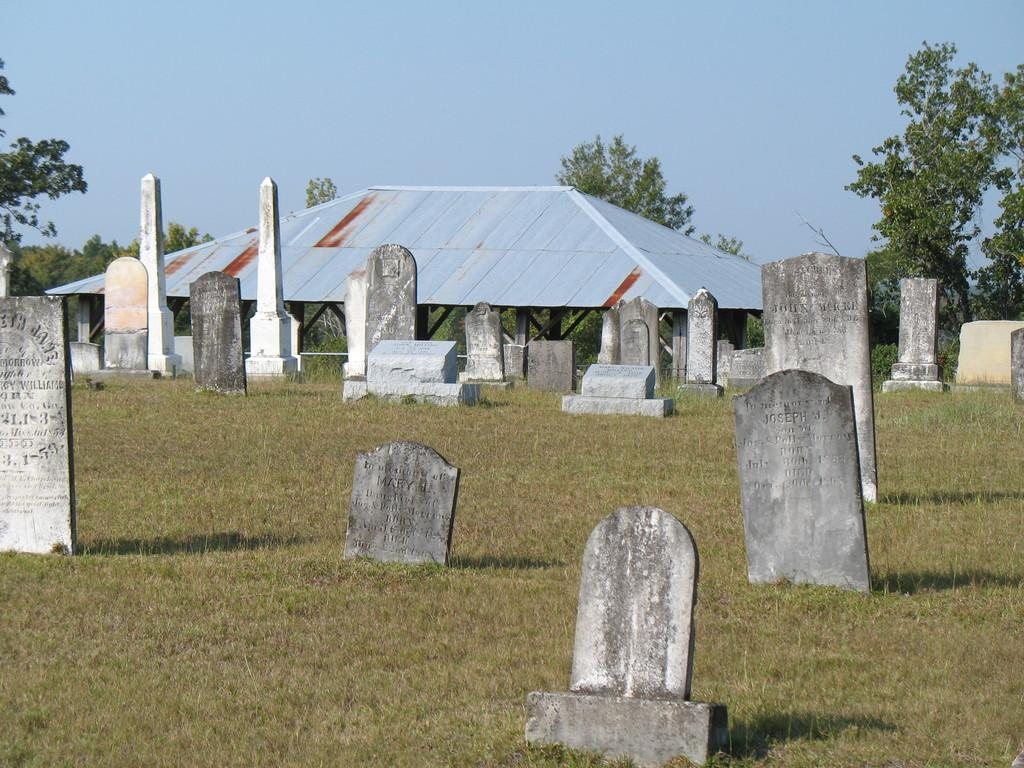What can be seen in the image that represents burial sites? There are graves in the image. What type of vegetation is present on the ground in the image? There is grass on the ground in the image. What structure can be seen in the background of the image? There is a shed in the background of the image. What else is visible in the background of the image besides the shed? There are trees and the sky visible in the background of the image. Can you tell me how many apples are on the trees in the image? There are no apples present in the image; it only features graves, grass, a shed, trees, and the sky. Is there a brother standing near the graves in the image? There is no brother present in the image; it only features graves, grass, a shed, trees, and the sky. 